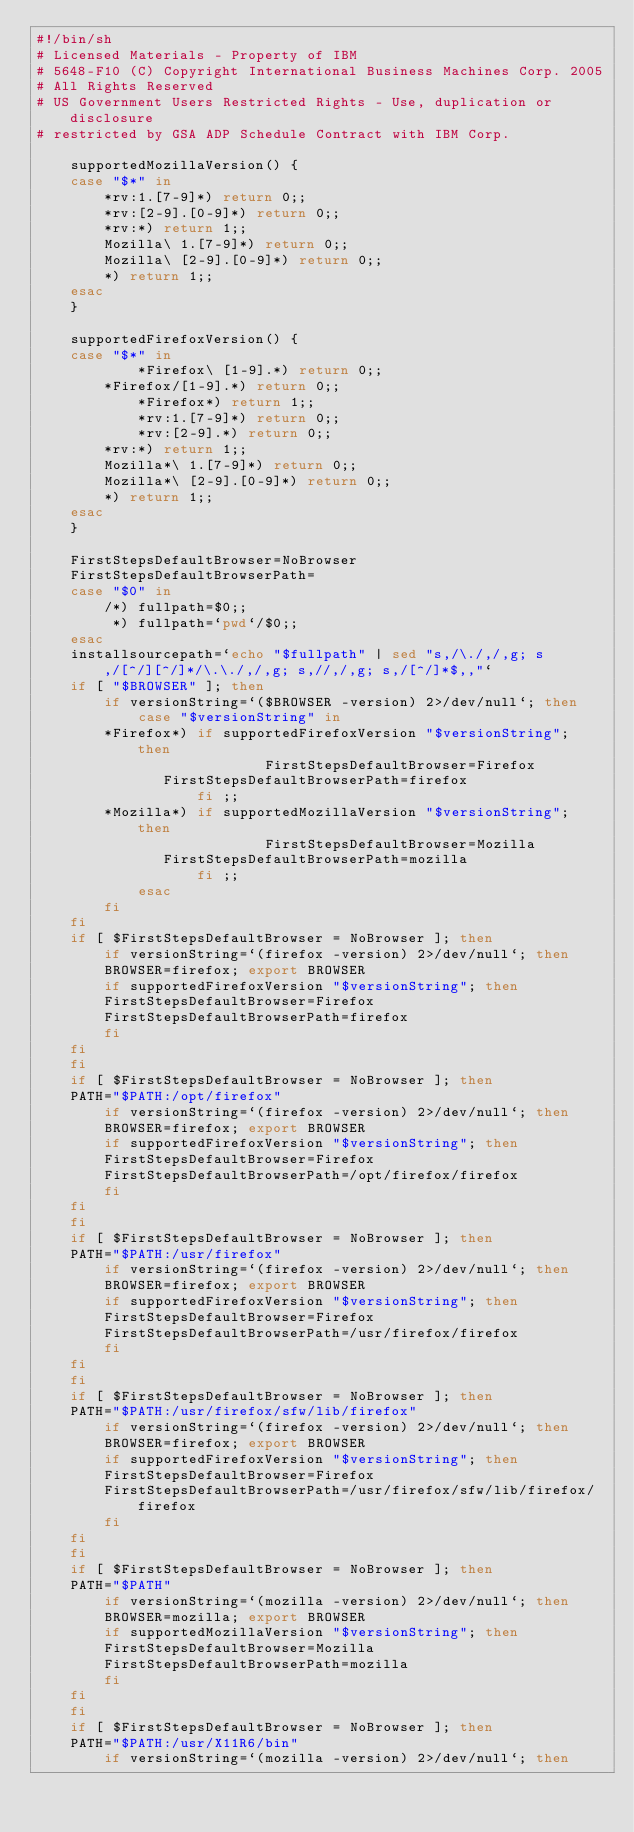Convert code to text. <code><loc_0><loc_0><loc_500><loc_500><_Bash_>#!/bin/sh
# Licensed Materials - Property of IBM
# 5648-F10 (C) Copyright International Business Machines Corp. 2005 
# All Rights Reserved
# US Government Users Restricted Rights - Use, duplication or disclosure
# restricted by GSA ADP Schedule Contract with IBM Corp.

    supportedMozillaVersion() {
	case "$*" in
	    *rv:1.[7-9]*) return 0;;
	    *rv:[2-9].[0-9]*) return 0;;
	    *rv:*) return 1;;
	    Mozilla\ 1.[7-9]*) return 0;;
	    Mozilla\ [2-9].[0-9]*) return 0;;
	    *) return 1;;
	esac
    }

    supportedFirefoxVersion() {
	case "$*" in
            *Firefox\ [1-9].*) return 0;;
	    *Firefox/[1-9].*) return 0;;
            *Firefox*) return 1;;
            *rv:1.[7-9]*) return 0;;
            *rv:[2-9].*) return 0;;
	    *rv:*) return 1;;
	    Mozilla*\ 1.[7-9]*) return 0;;
	    Mozilla*\ [2-9].[0-9]*) return 0;;
	    *) return 1;;
	esac
    }

    FirstStepsDefaultBrowser=NoBrowser
    FirstStepsDefaultBrowserPath=
    case "$0" in
        /*) fullpath=$0;;
         *) fullpath=`pwd`/$0;;
    esac
    installsourcepath=`echo "$fullpath" | sed "s,/\./,/,g; s,/[^/][^/]*/\.\./,/,g; s,//,/,g; s,/[^/]*$,,"`
    if [ "$BROWSER" ]; then
        if versionString=`($BROWSER -version) 2>/dev/null`; then
            case "$versionString" in
	    *Firefox*) if supportedFirefoxVersion "$versionString"; then
               	           FirstStepsDefaultBrowser=Firefox
			   FirstStepsDefaultBrowserPath=firefox
           	       fi ;;
	    *Mozilla*) if supportedMozillaVersion "$versionString"; then
               	           FirstStepsDefaultBrowser=Mozilla
			   FirstStepsDefaultBrowserPath=mozilla
           	       fi ;;
            esac
        fi
    fi
    if [ $FirstStepsDefaultBrowser = NoBrowser ]; then
        if versionString=`(firefox -version) 2>/dev/null`; then
	    BROWSER=firefox; export BROWSER
	    if supportedFirefoxVersion "$versionString"; then
		FirstStepsDefaultBrowser=Firefox
		FirstStepsDefaultBrowserPath=firefox
	    fi
	fi
    fi
    if [ $FirstStepsDefaultBrowser = NoBrowser ]; then
	PATH="$PATH:/opt/firefox"
        if versionString=`(firefox -version) 2>/dev/null`; then
	    BROWSER=firefox; export BROWSER
	    if supportedFirefoxVersion "$versionString"; then
		FirstStepsDefaultBrowser=Firefox
		FirstStepsDefaultBrowserPath=/opt/firefox/firefox
	    fi
	fi
    fi
    if [ $FirstStepsDefaultBrowser = NoBrowser ]; then
	PATH="$PATH:/usr/firefox"
        if versionString=`(firefox -version) 2>/dev/null`; then
	    BROWSER=firefox; export BROWSER
	    if supportedFirefoxVersion "$versionString"; then
		FirstStepsDefaultBrowser=Firefox
		FirstStepsDefaultBrowserPath=/usr/firefox/firefox
	    fi
	fi
    fi
    if [ $FirstStepsDefaultBrowser = NoBrowser ]; then
	PATH="$PATH:/usr/firefox/sfw/lib/firefox"
        if versionString=`(firefox -version) 2>/dev/null`; then
	    BROWSER=firefox; export BROWSER
	    if supportedFirefoxVersion "$versionString"; then
		FirstStepsDefaultBrowser=Firefox
		FirstStepsDefaultBrowserPath=/usr/firefox/sfw/lib/firefox/firefox
	    fi
	fi
    fi
    if [ $FirstStepsDefaultBrowser = NoBrowser ]; then
	PATH="$PATH"
        if versionString=`(mozilla -version) 2>/dev/null`; then
	    BROWSER=mozilla; export BROWSER
	    if supportedMozillaVersion "$versionString"; then
		FirstStepsDefaultBrowser=Mozilla
		FirstStepsDefaultBrowserPath=mozilla
	    fi
	fi
    fi
    if [ $FirstStepsDefaultBrowser = NoBrowser ]; then
	PATH="$PATH:/usr/X11R6/bin"
        if versionString=`(mozilla -version) 2>/dev/null`; then</code> 